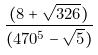<formula> <loc_0><loc_0><loc_500><loc_500>\frac { ( 8 + \sqrt { 3 2 6 } ) } { ( 4 7 0 ^ { 5 } - \sqrt { 5 } ) }</formula> 